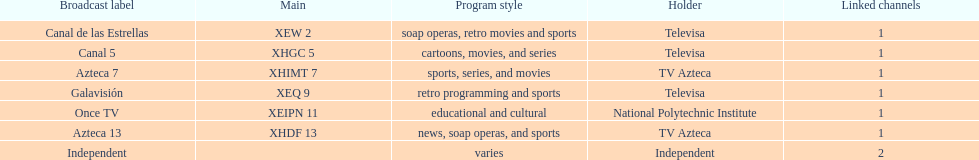What is the total number of affiliates among all the networks? 8. 